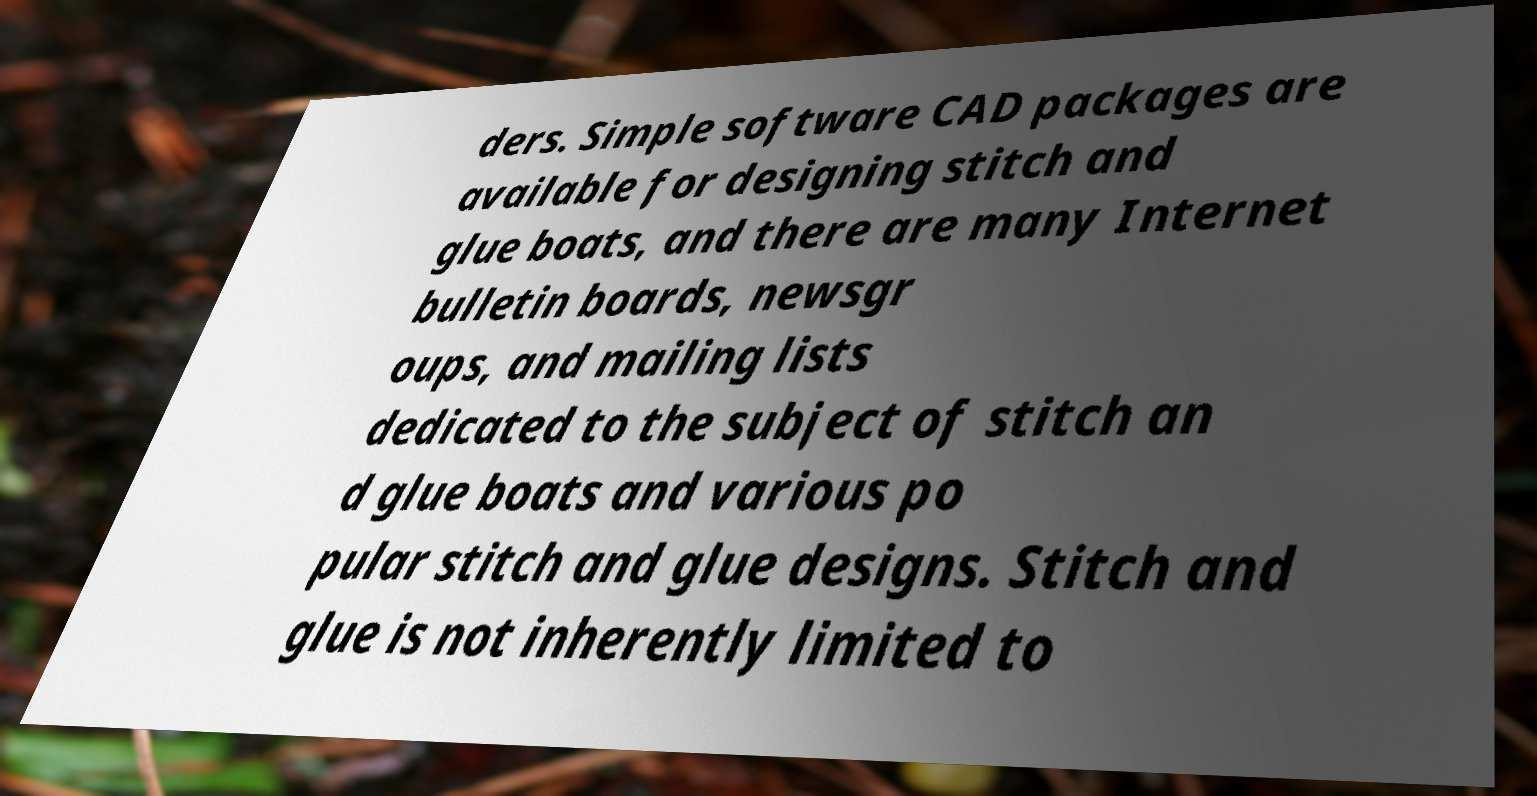Could you assist in decoding the text presented in this image and type it out clearly? ders. Simple software CAD packages are available for designing stitch and glue boats, and there are many Internet bulletin boards, newsgr oups, and mailing lists dedicated to the subject of stitch an d glue boats and various po pular stitch and glue designs. Stitch and glue is not inherently limited to 